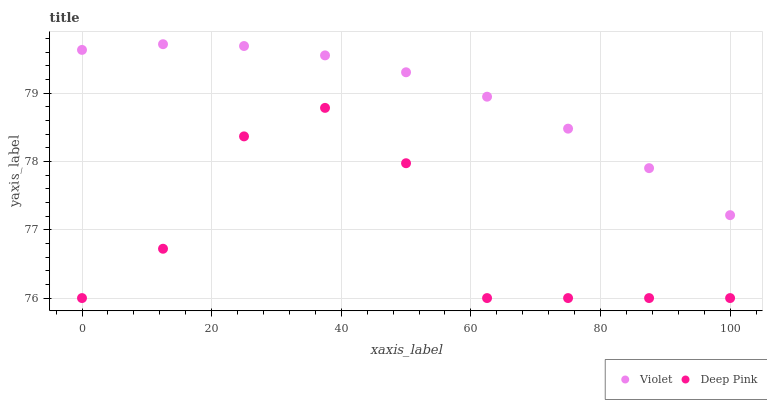Does Deep Pink have the minimum area under the curve?
Answer yes or no. Yes. Does Violet have the maximum area under the curve?
Answer yes or no. Yes. Does Violet have the minimum area under the curve?
Answer yes or no. No. Is Violet the smoothest?
Answer yes or no. Yes. Is Deep Pink the roughest?
Answer yes or no. Yes. Is Violet the roughest?
Answer yes or no. No. Does Deep Pink have the lowest value?
Answer yes or no. Yes. Does Violet have the lowest value?
Answer yes or no. No. Does Violet have the highest value?
Answer yes or no. Yes. Is Deep Pink less than Violet?
Answer yes or no. Yes. Is Violet greater than Deep Pink?
Answer yes or no. Yes. Does Deep Pink intersect Violet?
Answer yes or no. No. 